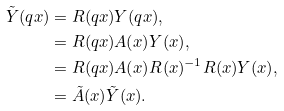Convert formula to latex. <formula><loc_0><loc_0><loc_500><loc_500>\tilde { Y } ( q x ) & = R ( q x ) Y ( q x ) , \\ & = R ( q x ) A ( x ) Y ( x ) , \\ & = R ( q x ) A ( x ) R ( x ) ^ { - 1 } R ( x ) Y ( x ) , \\ & = \tilde { A } ( x ) \tilde { Y } ( x ) .</formula> 